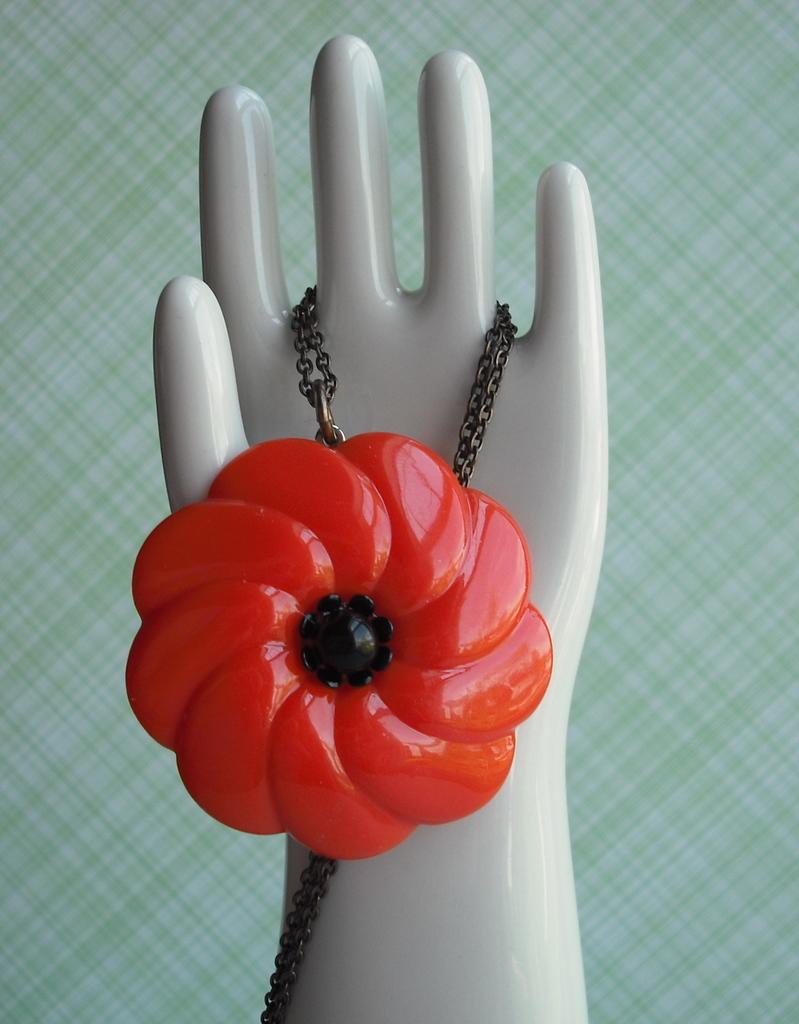What is the main object in the middle of the image? There is a chain in the middle of the image. What is unique about the chain? The chain has a red-colored locket. Where is the chain located? The chain is on a mannequin hand. What can be seen in the background of the image? There is a surface with many stripes in the background of the image. What type of plantation can be seen in the background of the image? There is no plantation present in the image; it features a surface with many stripes in the background. How does the mannequin hand's behavior change throughout the image? The mannequin hand does not exhibit any behavior, as it is an inanimate object in the image. 